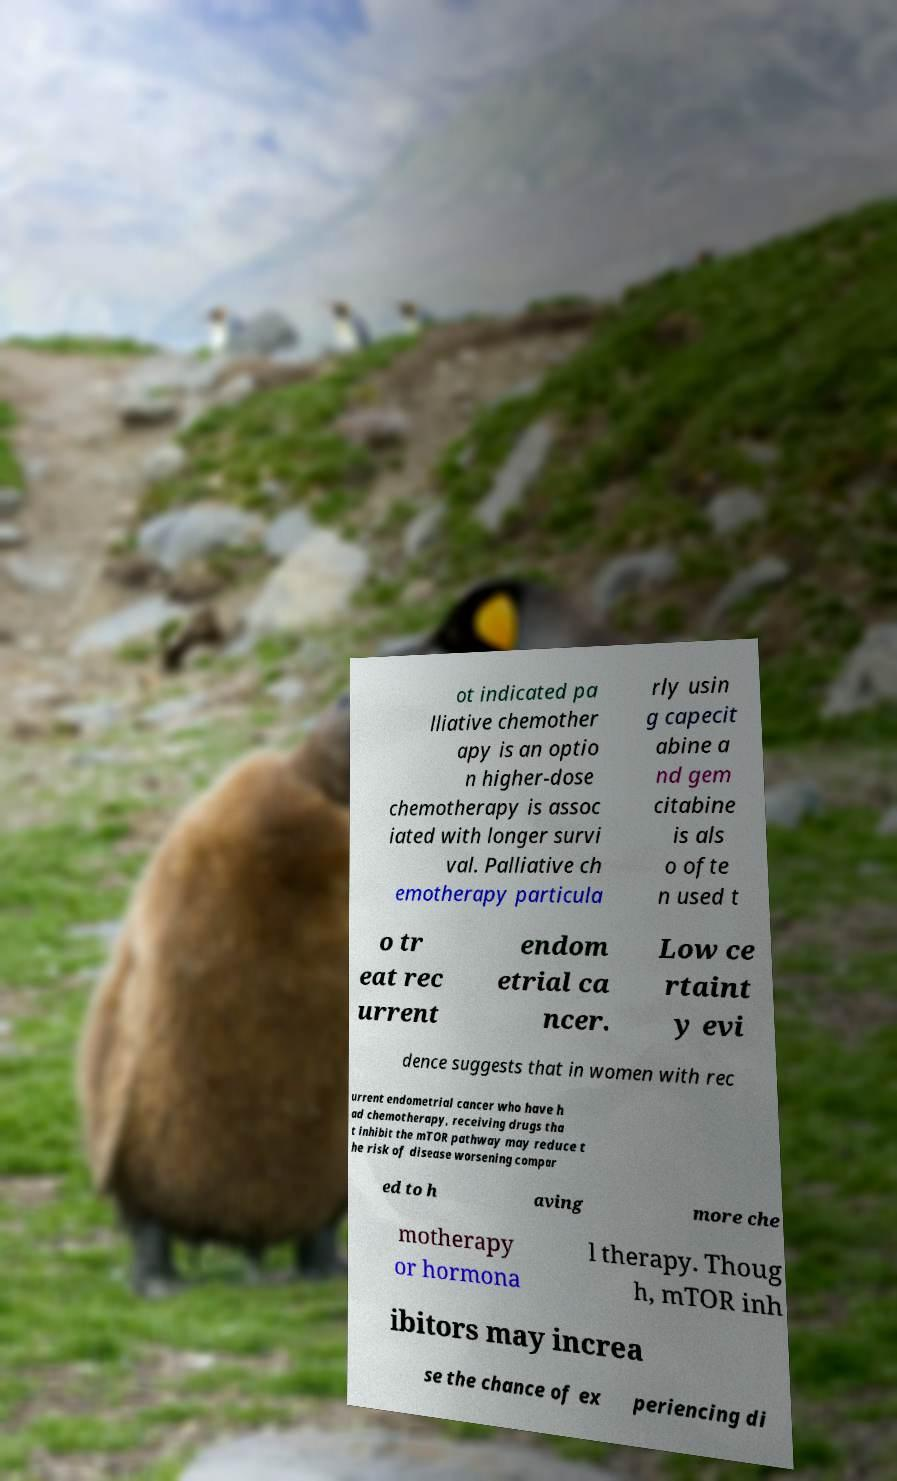What messages or text are displayed in this image? I need them in a readable, typed format. ot indicated pa lliative chemother apy is an optio n higher-dose chemotherapy is assoc iated with longer survi val. Palliative ch emotherapy particula rly usin g capecit abine a nd gem citabine is als o ofte n used t o tr eat rec urrent endom etrial ca ncer. Low ce rtaint y evi dence suggests that in women with rec urrent endometrial cancer who have h ad chemotherapy, receiving drugs tha t inhibit the mTOR pathway may reduce t he risk of disease worsening compar ed to h aving more che motherapy or hormona l therapy. Thoug h, mTOR inh ibitors may increa se the chance of ex periencing di 